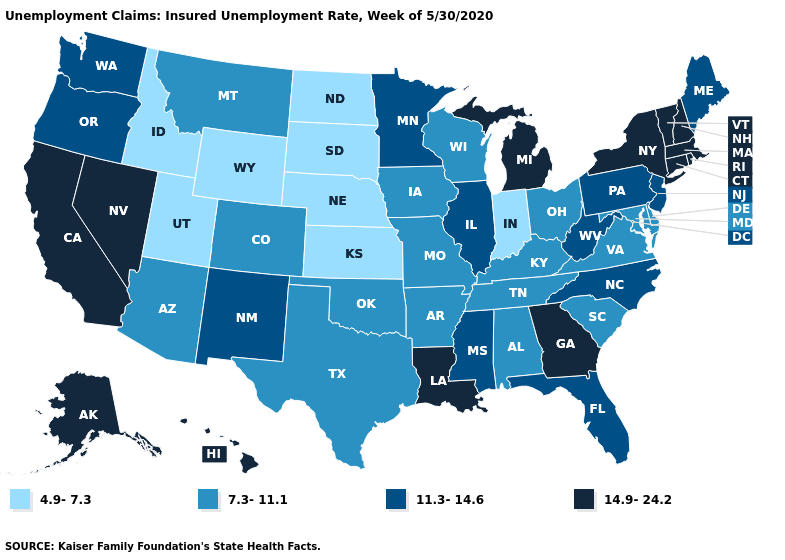Name the states that have a value in the range 11.3-14.6?
Give a very brief answer. Florida, Illinois, Maine, Minnesota, Mississippi, New Jersey, New Mexico, North Carolina, Oregon, Pennsylvania, Washington, West Virginia. Which states have the lowest value in the West?
Be succinct. Idaho, Utah, Wyoming. Name the states that have a value in the range 4.9-7.3?
Write a very short answer. Idaho, Indiana, Kansas, Nebraska, North Dakota, South Dakota, Utah, Wyoming. What is the value of North Dakota?
Be succinct. 4.9-7.3. What is the value of Colorado?
Write a very short answer. 7.3-11.1. Name the states that have a value in the range 7.3-11.1?
Quick response, please. Alabama, Arizona, Arkansas, Colorado, Delaware, Iowa, Kentucky, Maryland, Missouri, Montana, Ohio, Oklahoma, South Carolina, Tennessee, Texas, Virginia, Wisconsin. What is the value of Arizona?
Quick response, please. 7.3-11.1. What is the value of Vermont?
Answer briefly. 14.9-24.2. Which states hav the highest value in the West?
Quick response, please. Alaska, California, Hawaii, Nevada. Name the states that have a value in the range 4.9-7.3?
Short answer required. Idaho, Indiana, Kansas, Nebraska, North Dakota, South Dakota, Utah, Wyoming. Among the states that border California , does Arizona have the lowest value?
Quick response, please. Yes. Name the states that have a value in the range 4.9-7.3?
Be succinct. Idaho, Indiana, Kansas, Nebraska, North Dakota, South Dakota, Utah, Wyoming. Does Nevada have a lower value than Washington?
Be succinct. No. Does Ohio have the highest value in the USA?
Short answer required. No. 